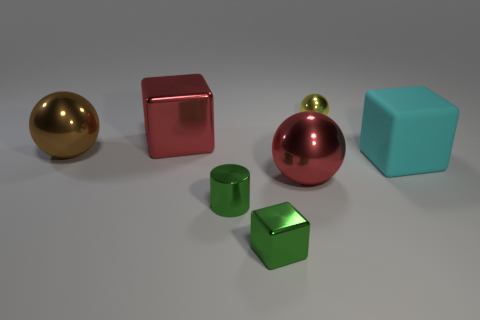Does the red thing that is left of the red ball have the same material as the big block that is on the right side of the green cylinder?
Your answer should be very brief. No. What number of metal objects are big objects or gray things?
Provide a short and direct response. 3. Is the shape of the large red shiny object that is in front of the large cyan rubber block the same as the big object on the right side of the tiny yellow ball?
Your answer should be compact. No. There is a small green metal cube; how many cyan matte things are in front of it?
Give a very brief answer. 0. Is there a red block made of the same material as the green block?
Your response must be concise. Yes. What material is the cyan thing that is the same size as the brown metal sphere?
Offer a terse response. Rubber. Is the material of the small yellow thing the same as the large cyan block?
Your answer should be very brief. No. How many things are either big cyan matte things or big metal balls?
Provide a short and direct response. 3. What is the shape of the small thing behind the red shiny ball?
Give a very brief answer. Sphere. There is a small cylinder that is the same material as the small yellow ball; what is its color?
Offer a terse response. Green. 